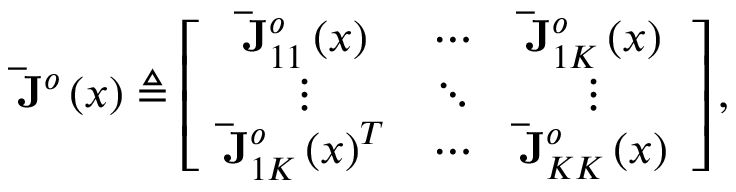Convert formula to latex. <formula><loc_0><loc_0><loc_500><loc_500>\bar { J } ^ { o } \left ( x \right ) \triangle q \left [ \begin{array} { c c c } { \bar { J } _ { 1 1 } ^ { o } \left ( x \right ) } & { \cdots } & { \bar { J } _ { 1 K } ^ { o } \left ( x \right ) } \\ { \vdots } & { \ddots } & { \vdots } \\ { \bar { J } _ { 1 K } ^ { o } \left ( x \right ) ^ { T } } & { \cdots } & { \bar { J } _ { K K } ^ { o } \left ( x \right ) } \end{array} \right ] ,</formula> 